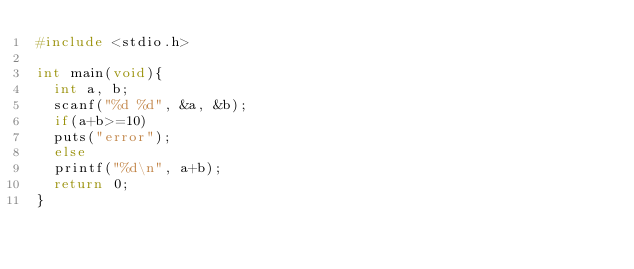<code> <loc_0><loc_0><loc_500><loc_500><_C_>#include <stdio.h>

int main(void){
  int a, b;
  scanf("%d %d", &a, &b);
  if(a+b>=10)
  puts("error");
  else
  printf("%d\n", a+b);
  return 0;
}
</code> 